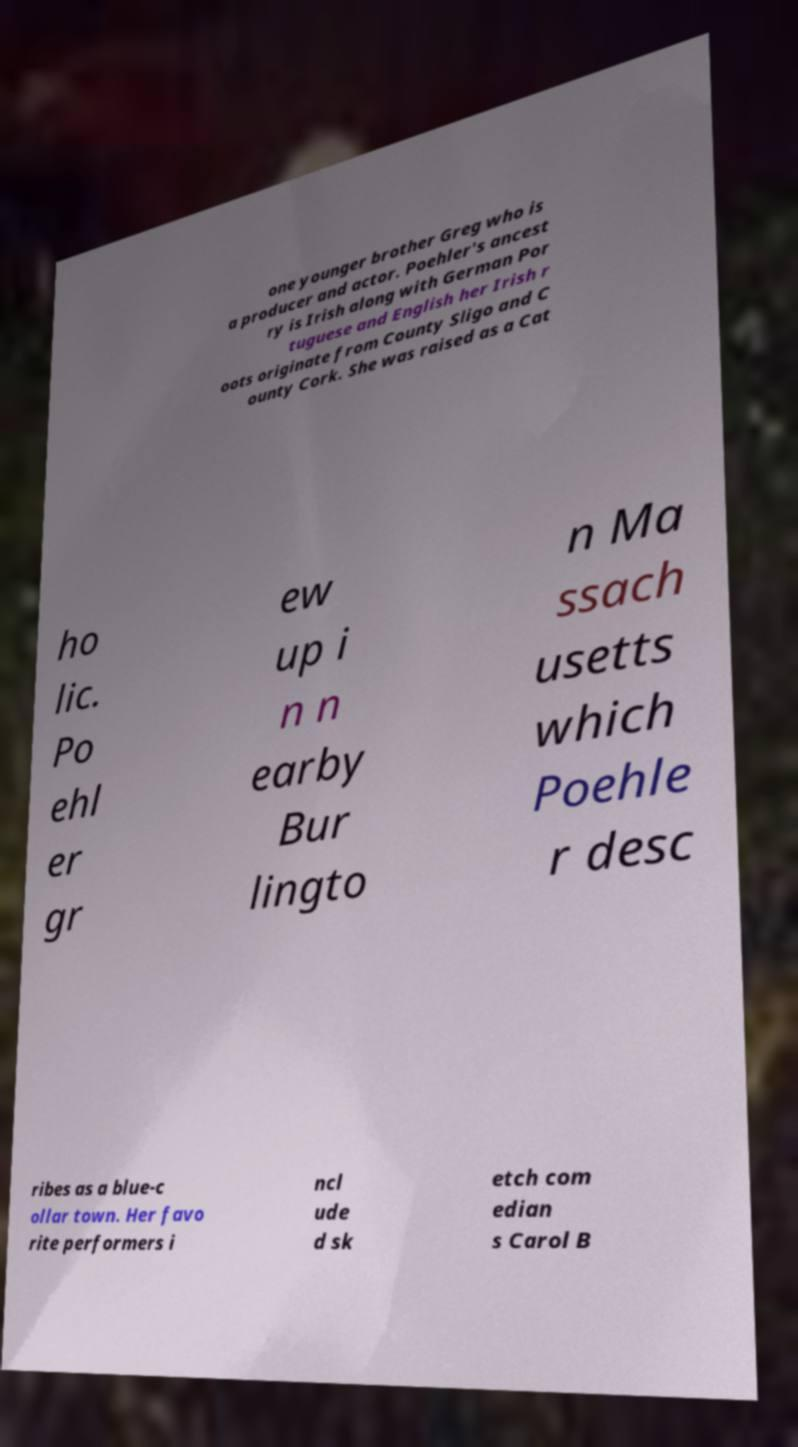Could you extract and type out the text from this image? one younger brother Greg who is a producer and actor. Poehler's ancest ry is Irish along with German Por tuguese and English her Irish r oots originate from County Sligo and C ounty Cork. She was raised as a Cat ho lic. Po ehl er gr ew up i n n earby Bur lingto n Ma ssach usetts which Poehle r desc ribes as a blue-c ollar town. Her favo rite performers i ncl ude d sk etch com edian s Carol B 